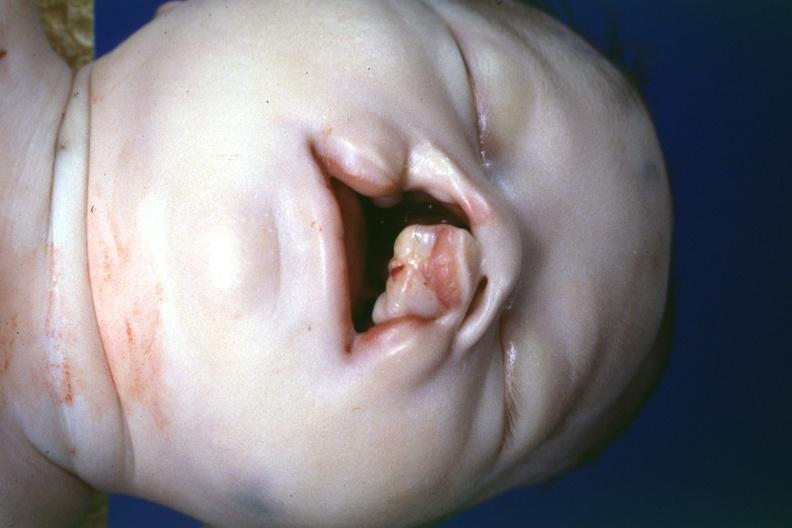does good example of muscle atrophy show left side lesion?
Answer the question using a single word or phrase. No 